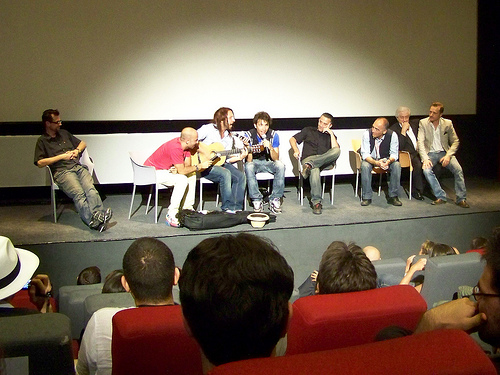<image>
Can you confirm if the man is to the left of the case? Yes. From this viewpoint, the man is positioned to the left side relative to the case. Is there a guitar next to the chair? No. The guitar is not positioned next to the chair. They are located in different areas of the scene. 